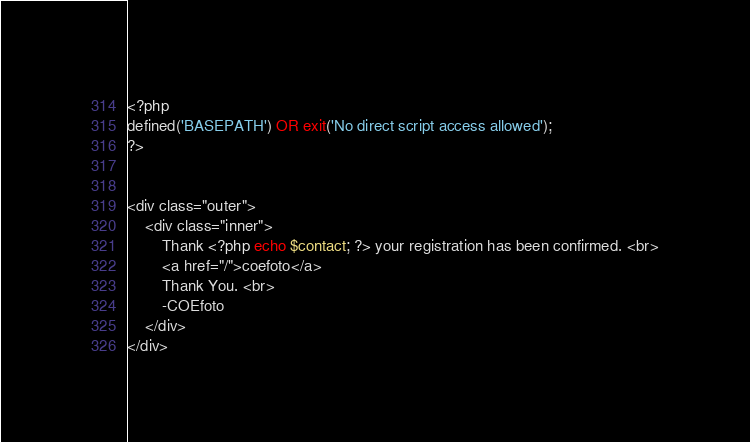<code> <loc_0><loc_0><loc_500><loc_500><_PHP_><?php
defined('BASEPATH') OR exit('No direct script access allowed');
?>


<div class="outer">
	<div class="inner">
		Thank <?php echo $contact; ?> your registration has been confirmed. <br>
		<a href="/">coefoto</a>
		Thank You. <br>
		-COEfoto
	</div>
</div></code> 